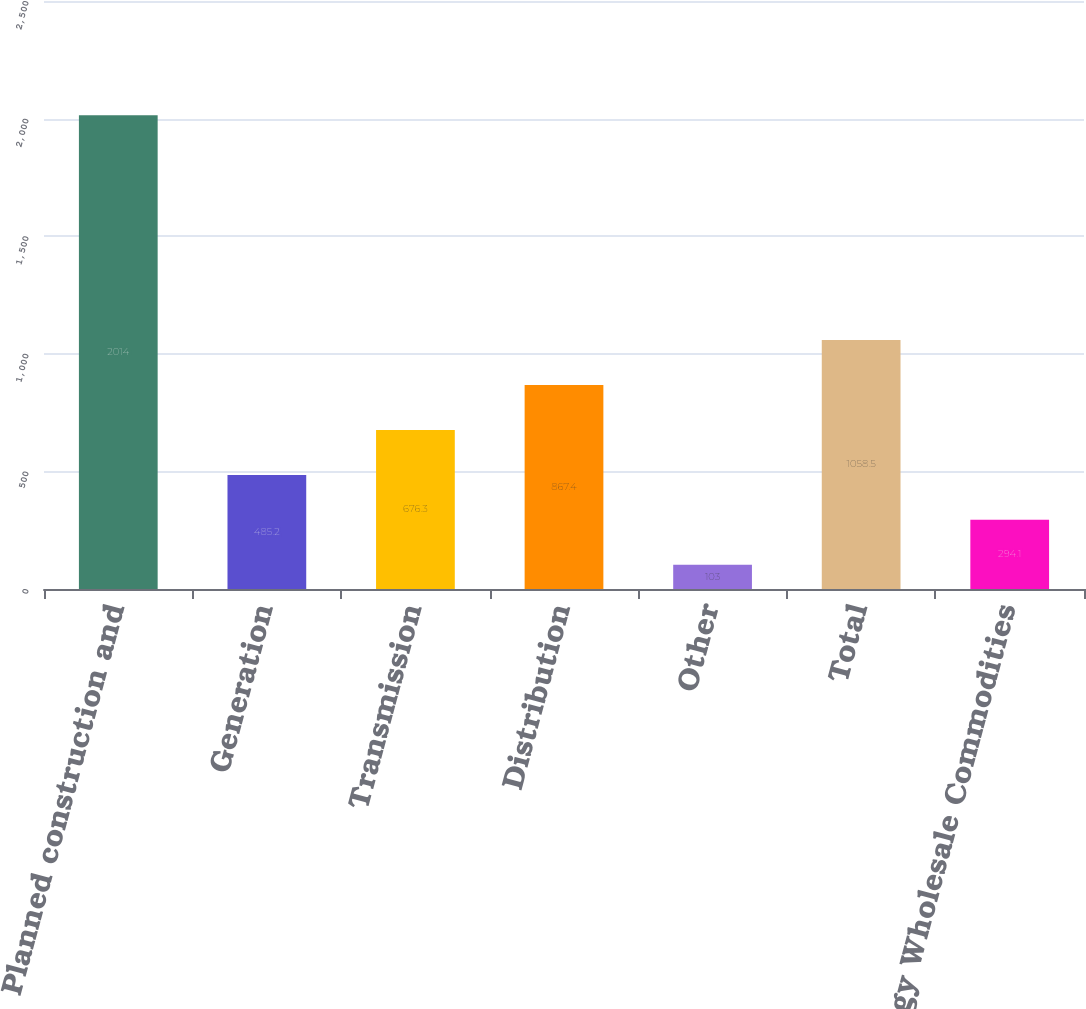Convert chart to OTSL. <chart><loc_0><loc_0><loc_500><loc_500><bar_chart><fcel>Planned construction and<fcel>Generation<fcel>Transmission<fcel>Distribution<fcel>Other<fcel>Total<fcel>Entergy Wholesale Commodities<nl><fcel>2014<fcel>485.2<fcel>676.3<fcel>867.4<fcel>103<fcel>1058.5<fcel>294.1<nl></chart> 